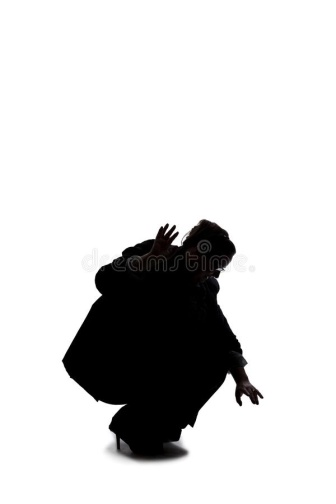Describe the following image. The image presents a dramatic and captivating scene depicted in high-contrast black and white. At the heart of the composition is a lone figure, their silhouette starkly highlighted against a pristine white background. The individual is crouched low, exuding an aura of tension or anticipation, with both arms extended forward, their fingers curled into claw-like shapes. This posture suggests an imminent action, adding to the dynamic and mysterious quality of the image. The stark simplicity of the background, devoid of any other elements, draws the viewer's attention solely to the figure, emphasizing their dramatic stance and creating a powerful visual narrative. The minimalism inherent in the design accentuates the emotional intensity and leaves much to the viewer's imagination regarding the context and story behind this striking portrayal. 